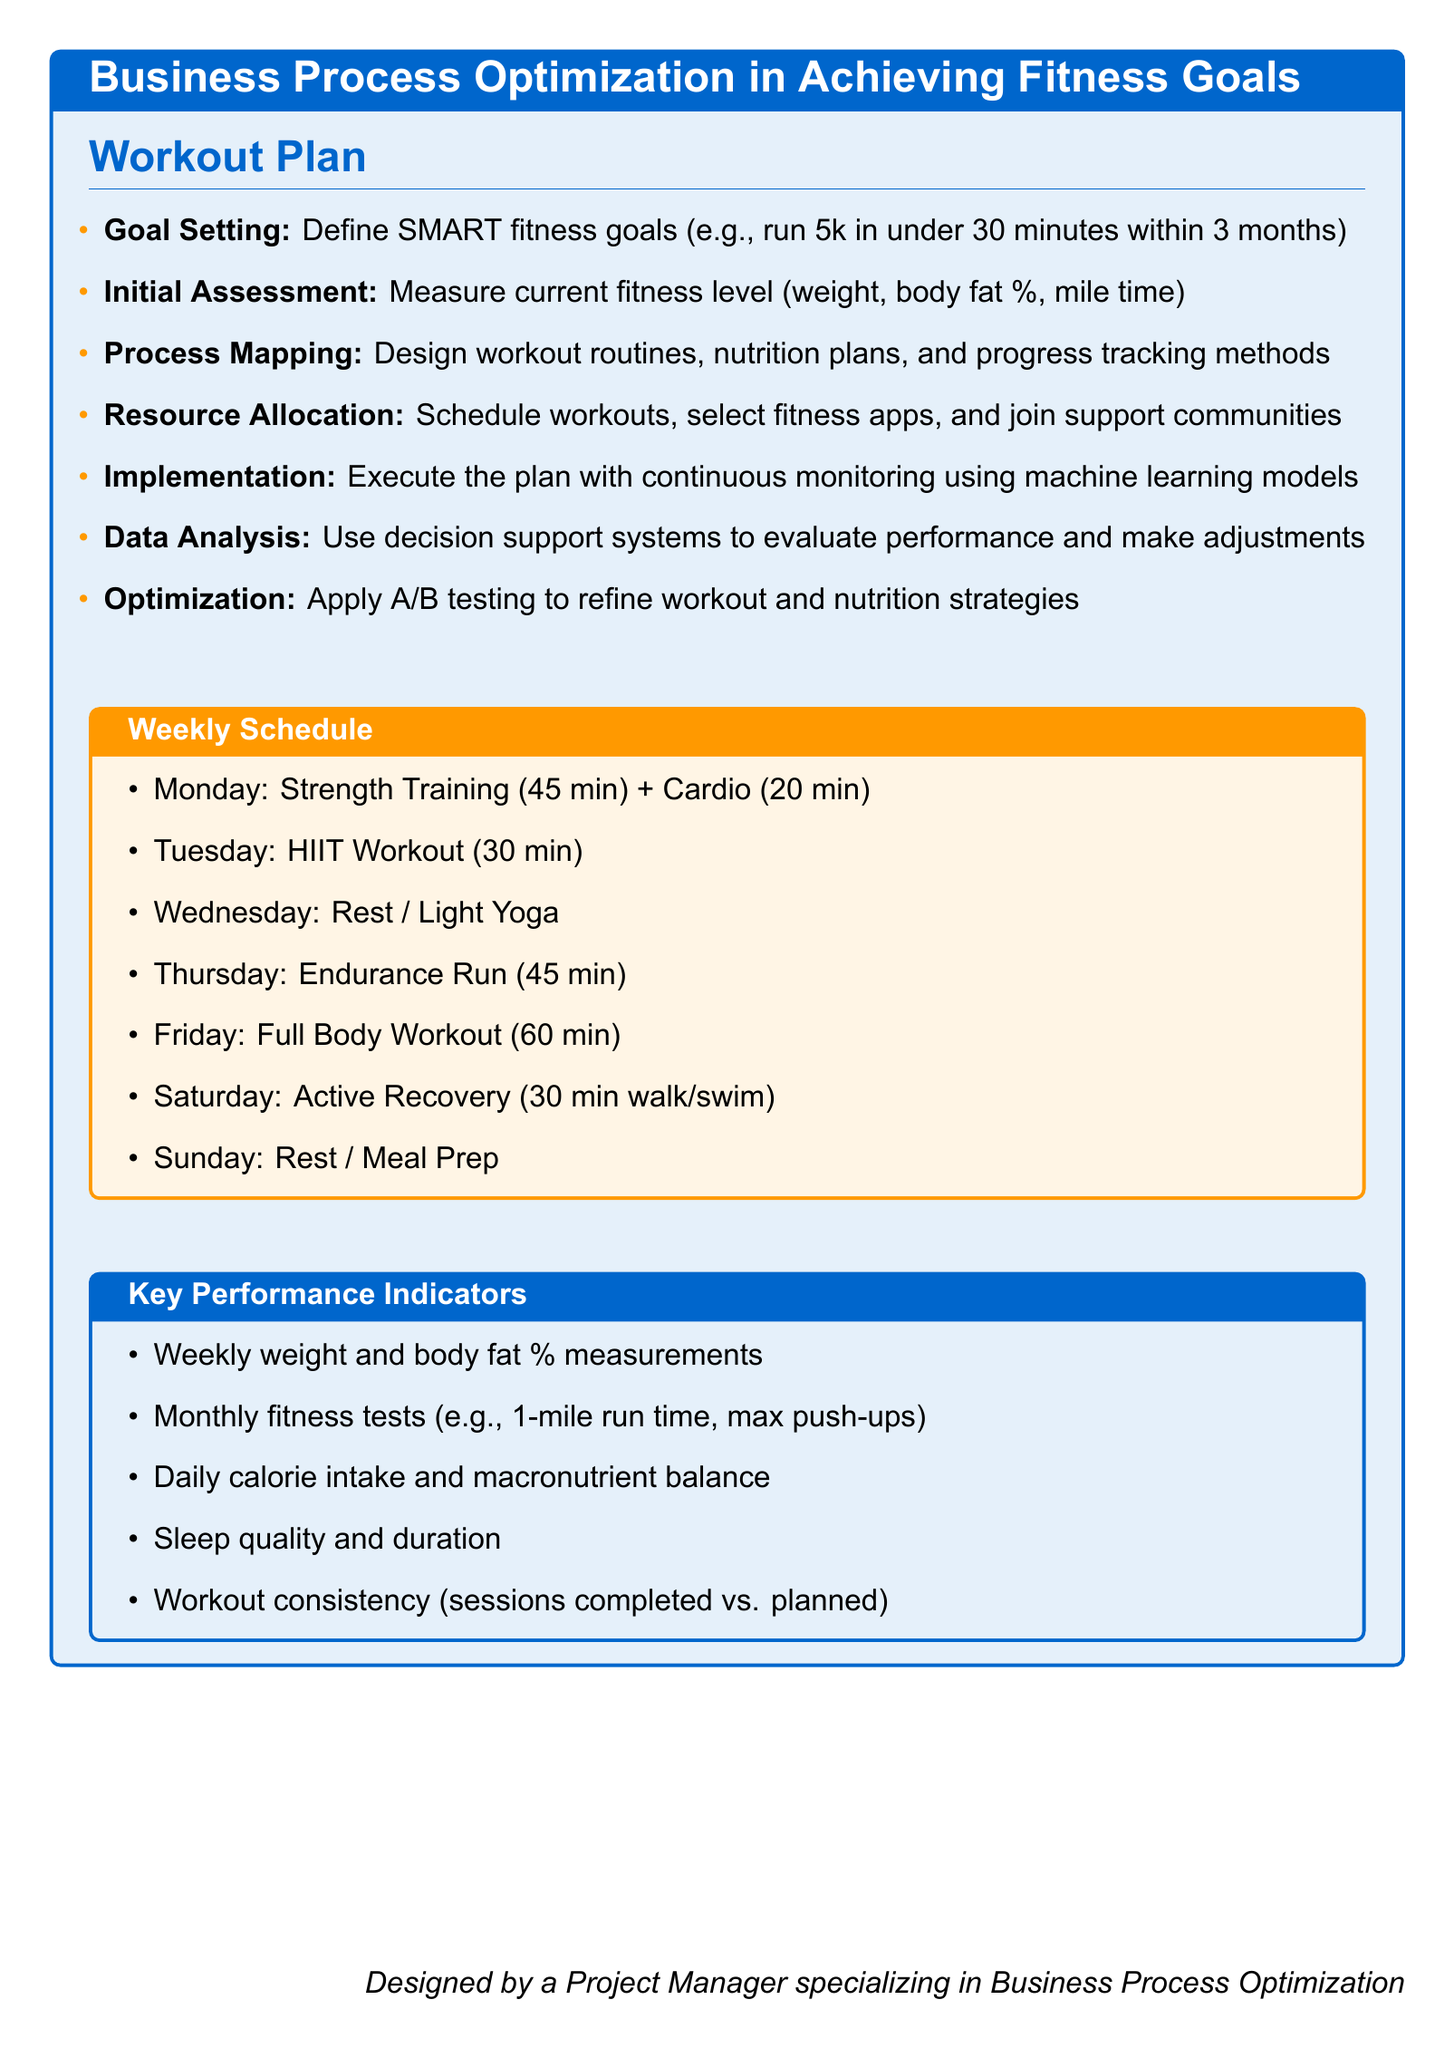What is the first step in the workout plan? The first step is mentioned in the section about Goal Setting, which includes defining SMART fitness goals.
Answer: Goal Setting How long is the endurance run planned for? The endurance run duration is specified under the Weekly Schedule section.
Answer: 45 min What performance measures are used weekly? Weekly weight and body fat percentage measurements are listed under Key Performance Indicators.
Answer: Weekly weight and body fat % What does the implementation phase involve? The implementation phase consists of executing the plan with continuous monitoring using machine learning models.
Answer: Execute the plan with continuous monitoring using machine learning models How many minutes is the HIIT workout scheduled for? The duration of the HIIT workout is mentioned in the Weekly Schedule section.
Answer: 30 min What type of activity is scheduled for Wednesday? The activity for Wednesday is stated in the Weekly Schedule section.
Answer: Rest / Light Yoga What is the method used to refine workout strategies? The method mentioned for refining workout and nutrition strategies is applied in the Optimization step of the plan.
Answer: A/B testing 